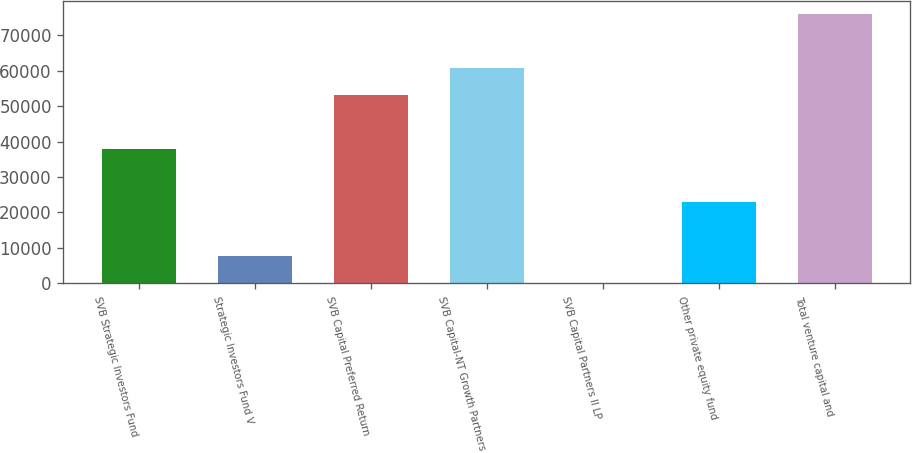Convert chart to OTSL. <chart><loc_0><loc_0><loc_500><loc_500><bar_chart><fcel>SVB Strategic Investors Fund<fcel>Strategic Investors Fund V<fcel>SVB Capital Preferred Return<fcel>SVB Capital-NT Growth Partners<fcel>SVB Capital Partners II LP<fcel>Other private equity fund<fcel>Total venture capital and<nl><fcel>37979.5<fcel>7648.7<fcel>53144.9<fcel>60727.6<fcel>66<fcel>22814.1<fcel>75893<nl></chart> 